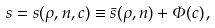<formula> <loc_0><loc_0><loc_500><loc_500>s = s ( \rho , n , c ) \equiv \bar { s } ( \rho , n ) + \Phi ( c ) \, ,</formula> 